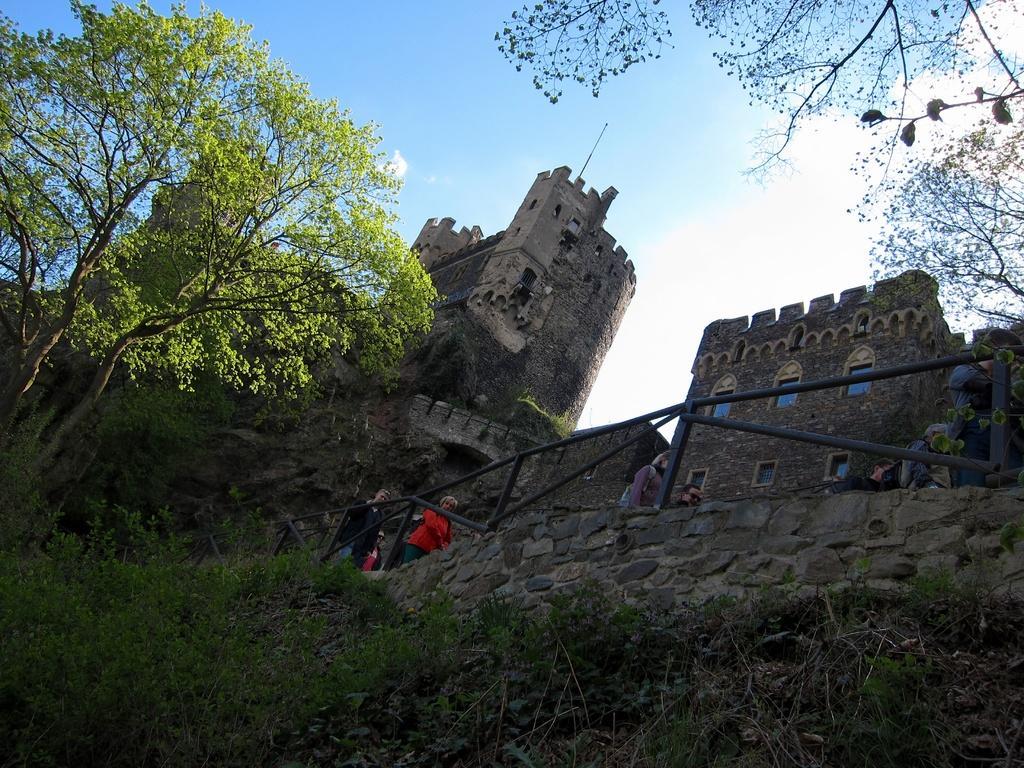Could you give a brief overview of what you see in this image? In this picture we can see a group of people standing at fence, trees, wall, buildings with windows and in the background we can see the sky with clouds. 